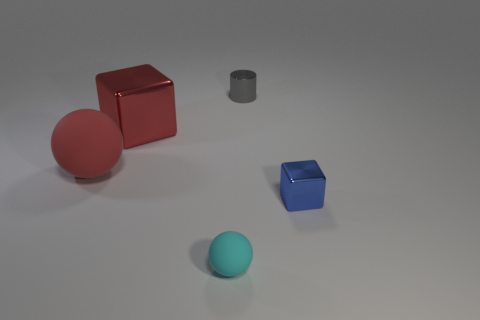There is a cube that is the same size as the cyan sphere; what color is it?
Provide a succinct answer. Blue. There is a cube to the left of the tiny rubber sphere; how many spheres are to the right of it?
Your answer should be compact. 1. How many rubber objects are both in front of the tiny blue metallic object and left of the small ball?
Give a very brief answer. 0. What number of things are either metal blocks that are behind the big rubber sphere or objects that are right of the large red shiny block?
Your answer should be compact. 4. What number of other things are the same size as the red metal block?
Your answer should be compact. 1. What is the shape of the metal object right of the small metal object to the left of the blue thing?
Offer a terse response. Cube. Does the block on the left side of the blue metal cube have the same color as the matte thing behind the small blue object?
Offer a terse response. Yes. Is there anything else of the same color as the big matte sphere?
Offer a very short reply. Yes. The large block is what color?
Provide a succinct answer. Red. Are there any red metal things?
Give a very brief answer. Yes. 